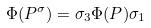Convert formula to latex. <formula><loc_0><loc_0><loc_500><loc_500>\Phi ( P ^ { \sigma } ) = \sigma _ { 3 } \Phi ( P ) \sigma _ { 1 }</formula> 